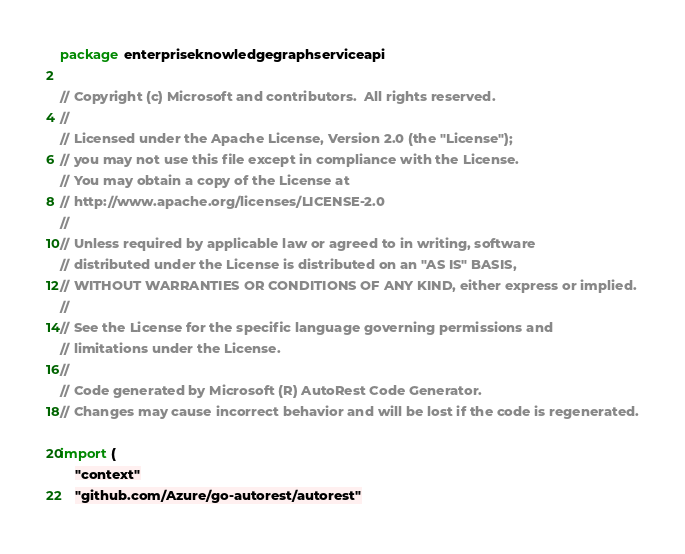<code> <loc_0><loc_0><loc_500><loc_500><_Go_>package enterpriseknowledgegraphserviceapi

// Copyright (c) Microsoft and contributors.  All rights reserved.
//
// Licensed under the Apache License, Version 2.0 (the "License");
// you may not use this file except in compliance with the License.
// You may obtain a copy of the License at
// http://www.apache.org/licenses/LICENSE-2.0
//
// Unless required by applicable law or agreed to in writing, software
// distributed under the License is distributed on an "AS IS" BASIS,
// WITHOUT WARRANTIES OR CONDITIONS OF ANY KIND, either express or implied.
//
// See the License for the specific language governing permissions and
// limitations under the License.
//
// Code generated by Microsoft (R) AutoRest Code Generator.
// Changes may cause incorrect behavior and will be lost if the code is regenerated.

import (
	"context"
	"github.com/Azure/go-autorest/autorest"</code> 